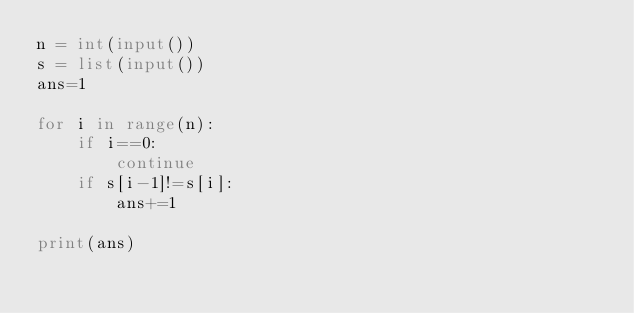<code> <loc_0><loc_0><loc_500><loc_500><_Python_>n = int(input())
s = list(input())
ans=1

for i in range(n):
    if i==0:
        continue
    if s[i-1]!=s[i]:
        ans+=1

print(ans)</code> 